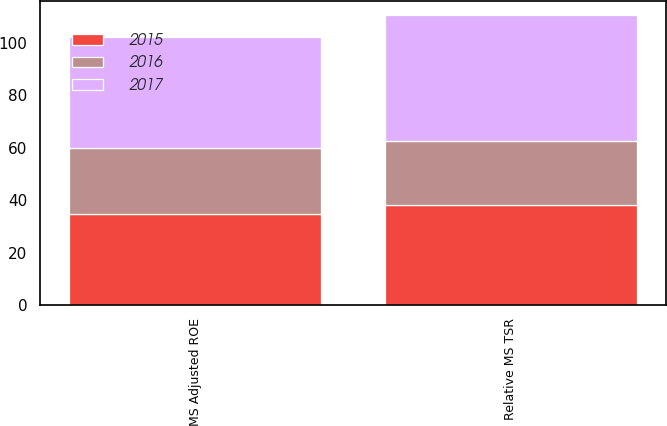Convert chart to OTSL. <chart><loc_0><loc_0><loc_500><loc_500><stacked_bar_chart><ecel><fcel>MS Adjusted ROE<fcel>Relative MS TSR<nl><fcel>2017<fcel>42.64<fcel>48.02<nl><fcel>2016<fcel>25.19<fcel>24.51<nl><fcel>2015<fcel>34.58<fcel>38.07<nl></chart> 